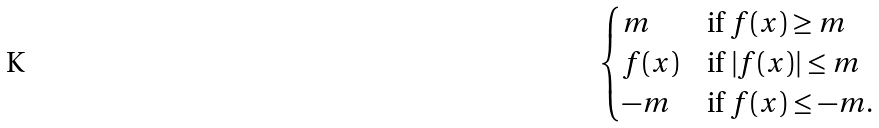Convert formula to latex. <formula><loc_0><loc_0><loc_500><loc_500>\begin{cases} m & \text {if } f ( x ) \geq m \\ f ( x ) & \text {if } | f ( x ) | \leq m \\ - m & \text {if } f ( x ) \leq - m . \end{cases}</formula> 